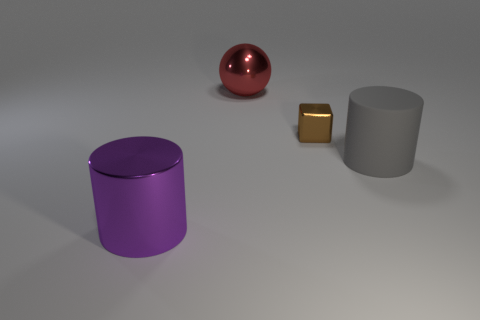Are there any other things that have the same material as the purple cylinder?
Keep it short and to the point. Yes. There is a purple object; what number of small things are on the right side of it?
Provide a short and direct response. 1. There is a purple metal object that is the same shape as the gray thing; what is its size?
Your answer should be compact. Large. What size is the object that is in front of the brown thing and to the right of the big red metal object?
Provide a succinct answer. Large. Do the matte object and the shiny object that is right of the red metal ball have the same color?
Offer a very short reply. No. How many cyan things are matte cylinders or large spheres?
Keep it short and to the point. 0. The tiny brown metallic object has what shape?
Keep it short and to the point. Cube. How many other things are there of the same shape as the red object?
Your answer should be compact. 0. What color is the cylinder that is behind the purple cylinder?
Offer a terse response. Gray. Does the brown block have the same material as the large red thing?
Make the answer very short. Yes. 